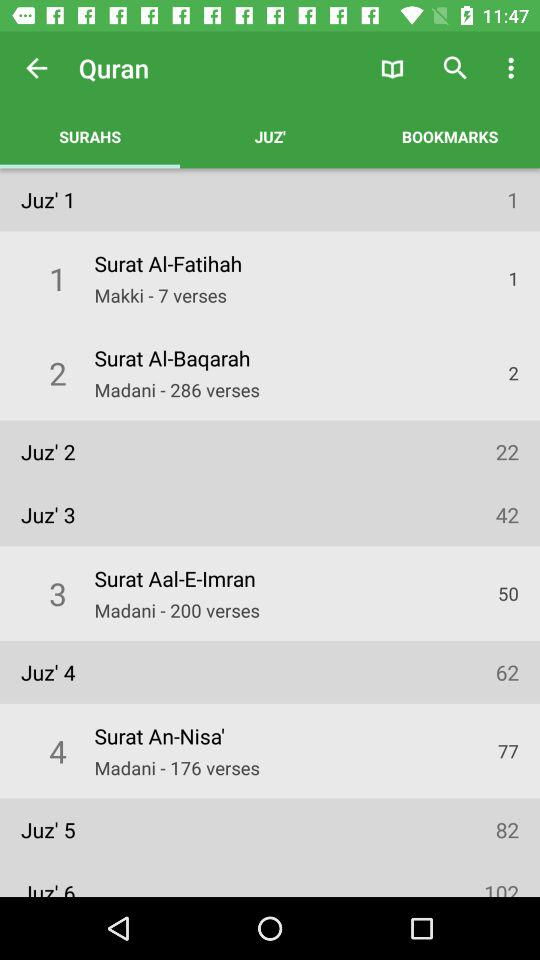How many verses are in Juz 3?
Answer the question using a single word or phrase. 42 